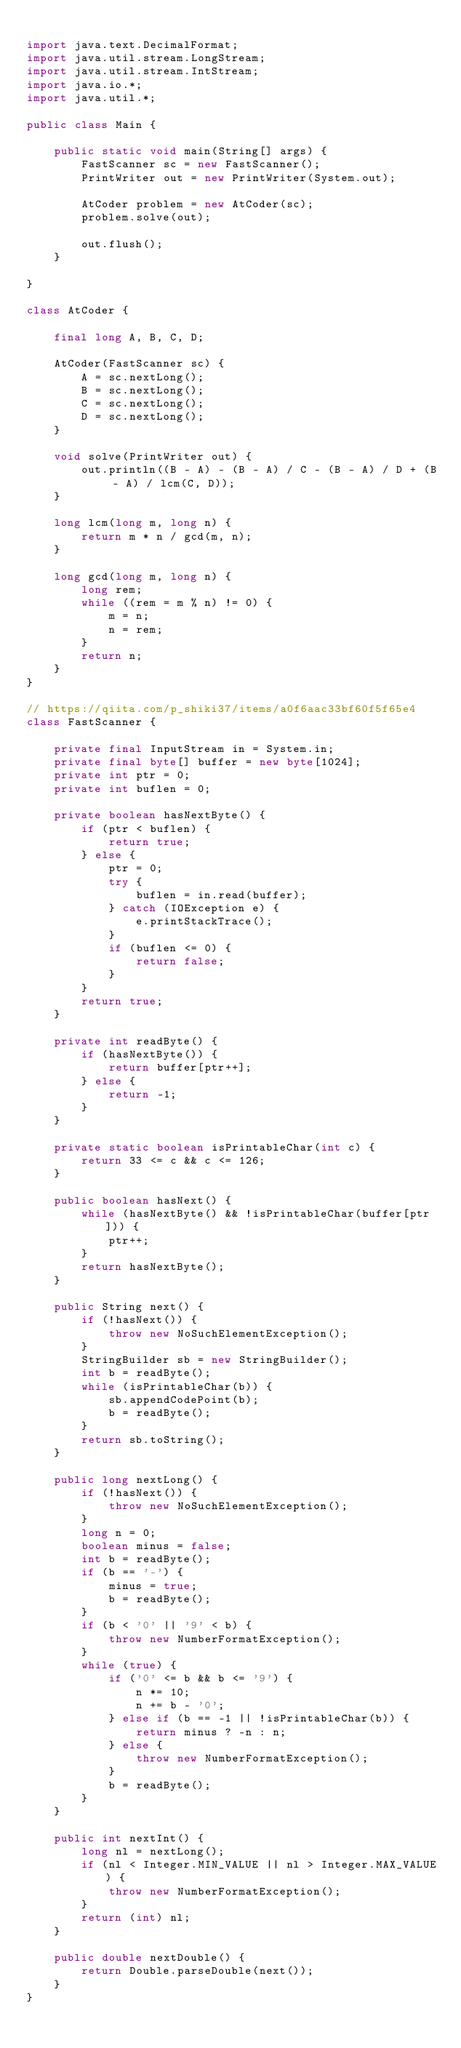<code> <loc_0><loc_0><loc_500><loc_500><_Java_>
import java.text.DecimalFormat;
import java.util.stream.LongStream;
import java.util.stream.IntStream;
import java.io.*;
import java.util.*;

public class Main {

    public static void main(String[] args) {
        FastScanner sc = new FastScanner();
        PrintWriter out = new PrintWriter(System.out);

        AtCoder problem = new AtCoder(sc);
        problem.solve(out);

        out.flush();
    }

}

class AtCoder {

    final long A, B, C, D;

    AtCoder(FastScanner sc) {
        A = sc.nextLong();
        B = sc.nextLong();
        C = sc.nextLong();
        D = sc.nextLong();
    }

    void solve(PrintWriter out) {
        out.println((B - A) - (B - A) / C - (B - A) / D + (B - A) / lcm(C, D));
    }

    long lcm(long m, long n) {
        return m * n / gcd(m, n);
    }

    long gcd(long m, long n) {
        long rem;
        while ((rem = m % n) != 0) {
            m = n;
            n = rem;
        }
        return n;
    }
}

// https://qiita.com/p_shiki37/items/a0f6aac33bf60f5f65e4
class FastScanner {

    private final InputStream in = System.in;
    private final byte[] buffer = new byte[1024];
    private int ptr = 0;
    private int buflen = 0;

    private boolean hasNextByte() {
        if (ptr < buflen) {
            return true;
        } else {
            ptr = 0;
            try {
                buflen = in.read(buffer);
            } catch (IOException e) {
                e.printStackTrace();
            }
            if (buflen <= 0) {
                return false;
            }
        }
        return true;
    }

    private int readByte() {
        if (hasNextByte()) {
            return buffer[ptr++];
        } else {
            return -1;
        }
    }

    private static boolean isPrintableChar(int c) {
        return 33 <= c && c <= 126;
    }

    public boolean hasNext() {
        while (hasNextByte() && !isPrintableChar(buffer[ptr])) {
            ptr++;
        }
        return hasNextByte();
    }

    public String next() {
        if (!hasNext()) {
            throw new NoSuchElementException();
        }
        StringBuilder sb = new StringBuilder();
        int b = readByte();
        while (isPrintableChar(b)) {
            sb.appendCodePoint(b);
            b = readByte();
        }
        return sb.toString();
    }

    public long nextLong() {
        if (!hasNext()) {
            throw new NoSuchElementException();
        }
        long n = 0;
        boolean minus = false;
        int b = readByte();
        if (b == '-') {
            minus = true;
            b = readByte();
        }
        if (b < '0' || '9' < b) {
            throw new NumberFormatException();
        }
        while (true) {
            if ('0' <= b && b <= '9') {
                n *= 10;
                n += b - '0';
            } else if (b == -1 || !isPrintableChar(b)) {
                return minus ? -n : n;
            } else {
                throw new NumberFormatException();
            }
            b = readByte();
        }
    }

    public int nextInt() {
        long nl = nextLong();
        if (nl < Integer.MIN_VALUE || nl > Integer.MAX_VALUE) {
            throw new NumberFormatException();
        }
        return (int) nl;
    }

    public double nextDouble() {
        return Double.parseDouble(next());
    }
}
</code> 